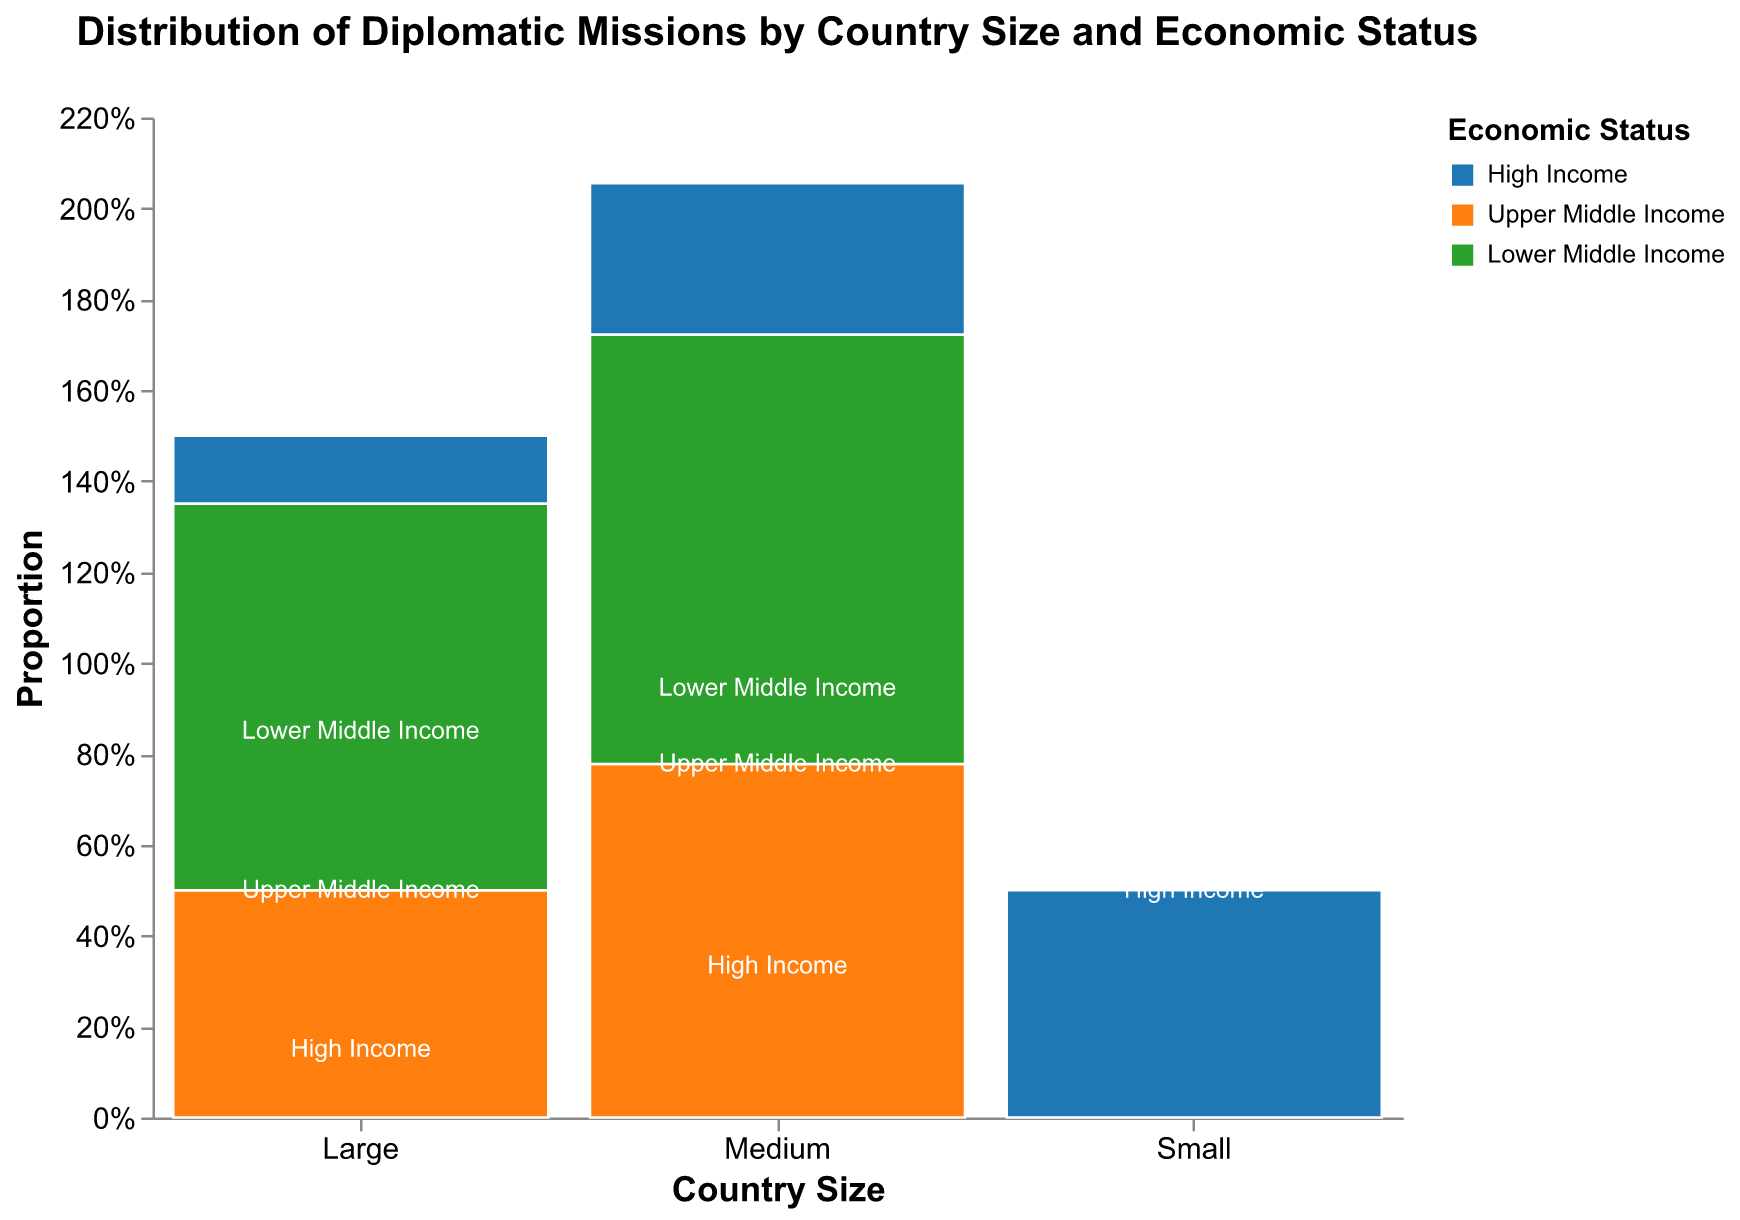What is the title of the figure? The title is located at the top of the figure, often indicating its main subject. Here, the title directly states the focus of the data being presented.
Answer: Distribution of Diplomatic Missions by Country Size and Economic Status Which country size category has the largest overall proportion of diplomatic missions? By examining the widths of the bars for each country size, the largest bar width will indicate the category with the largest overall proportion.
Answer: Large Which economic status has the highest proportion of diplomatic missions within 'Medium'-sized countries? Look at the 'Medium' section and identify which color, representing an economic status, occupies the greatest vertical space.
Answer: High Income Compare the proportion of diplomatic missions for 'Upper Middle Income' countries between Large and Medium sizes. Find the proportion of 'Upper Middle Income' missions in both Large and Medium categories by comparing the vertical space they occupy within their respective sections.
Answer: Larger in Large than in Medium Which size and economic status combination has the smallest proportion of diplomatic missions? Identify the smallest vertical section of any color across all sizes to find this combination.
Answer: Large & Lower Middle Income How do 'Lower Middle Income' countries compare between Medium and Large sizes in terms of diplomatic mission proportions? Compare the proportions by looking at the relative heights of the green sections within the Medium and Large size categories.
Answer: Larger in Medium than in Large What is the proportion of diplomatic missions from 'High Income' countries in the 'Small' size category? Identify the 'Small' category and look for the blue section; measure its height relative to the total height of 'Small'.
Answer: It's the only section, so 100% If you sum the proportions of 'High Income' missions from Medium and Small size categories, what's the total proportion? Add the proportion of 'High Income' missions from Medium (sum of blue sections) and Small categories (100%).
Answer: Greater than 100% due to scaling Which economic status has a higher proportion of diplomatic missions in the 'Large' category: 'Upper Middle Income' or 'Lower Middle Income'? Compare the heights of the orange ('Upper Middle Income') and green ('Lower Middle Income') sections within the Large category.
Answer: Upper Middle Income 